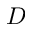Convert formula to latex. <formula><loc_0><loc_0><loc_500><loc_500>D</formula> 